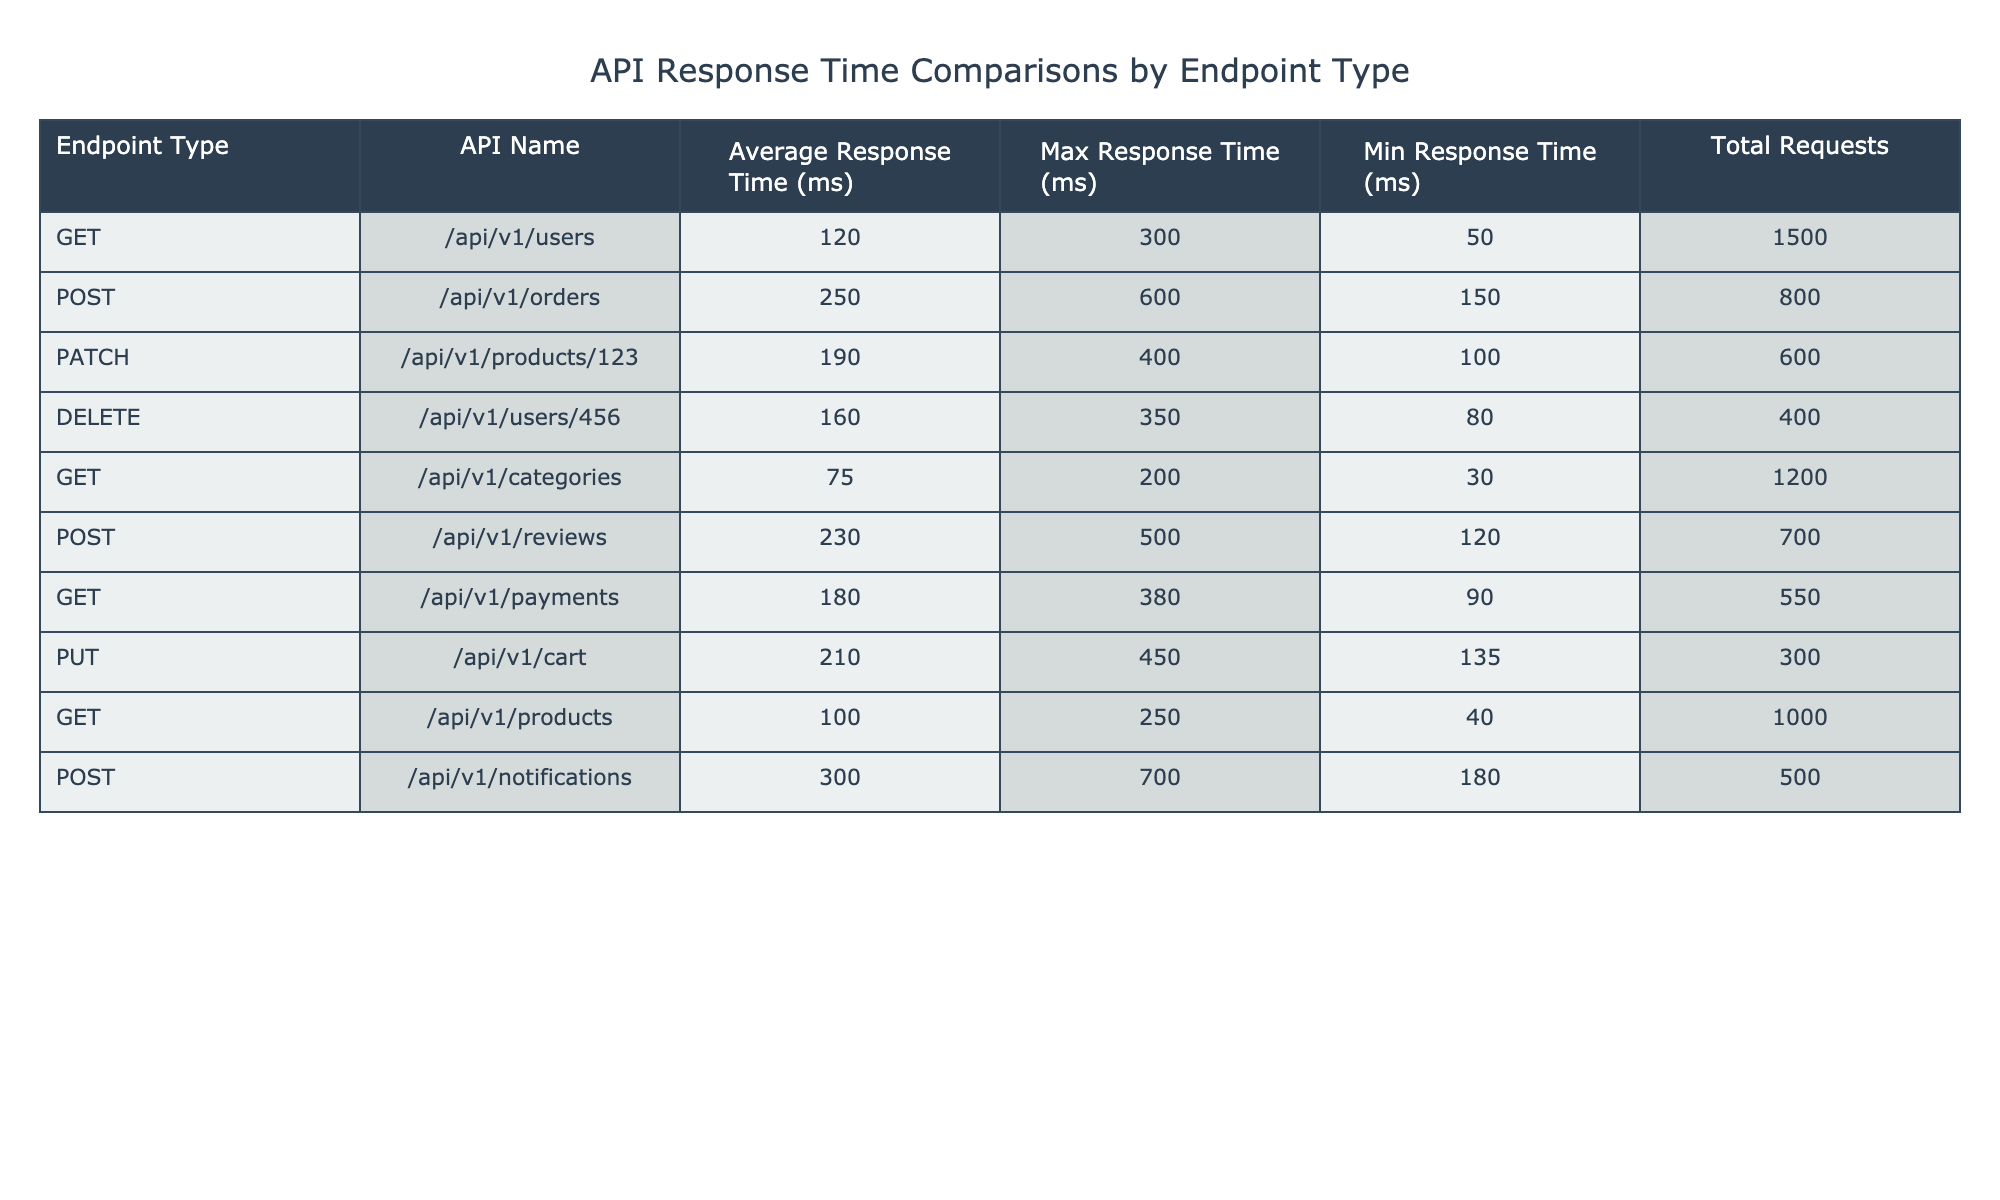What is the average response time for the POST endpoint type? The average response times for POST endpoints are 250 ms for orders, 230 ms for reviews, and 300 ms for notifications. To find the average: (250 + 230 + 300) / 3 = 260 ms.
Answer: 260 ms Which endpoint has the highest maximum response time? Checking the maximum response times, the POST endpoint for notifications has 700 ms, which is higher than the others.
Answer: POST /api/v1/notifications How many total requests were made for the GET endpoints? The GET endpoints are for users (1500 requests), categories (1200 requests), payments (550 requests), and products (1000 requests). Adding them gives: 1500 + 1200 + 550 + 1000 = 3250 requests.
Answer: 3250 requests Are there any endpoints with a minimum response time of less than 50 ms? The minimum response times are 50 ms for users and post requests of 120 ms for reviews. The minimum among all endpoints is 30 ms for categories, so there is one endpoint that meets the criteria.
Answer: Yes What is the response time difference between the POST and GET endpoint types? The average response times are 260 ms for POST and 118.75 ms for GET (adding 120 + 75 + 180 + 100 / 4). The difference is: 260 - 118.75 = 141.25 ms.
Answer: 141.25 ms Which endpoint type has the least total requests? The DELETE endpoint type for users has 400 requests, which is fewer than any other endpoint.
Answer: DELETE /api/v1/users/456 What is the average maximum response time across all endpoints? The maximum response times are 300, 600, 400, 350, 200, 500, 380, 450, 250, and 700. The sum is: 300 + 600 + 400 + 350 + 200 + 500 + 380 + 450 + 250 + 700 = 4180 ms, and the average is 4180 / 10 = 418 ms.
Answer: 418 ms Is the average response time for GET endpoints lower than 150 ms? The average response time for GET endpoints is (120 + 75 + 180 + 100) / 4 = 118.75 ms, which is lower than 150 ms.
Answer: Yes Which endpoint has the highest average response time? Among the average response times, POST /api/v1/notifications has the highest at 300 ms.
Answer: POST /api/v1/notifications 